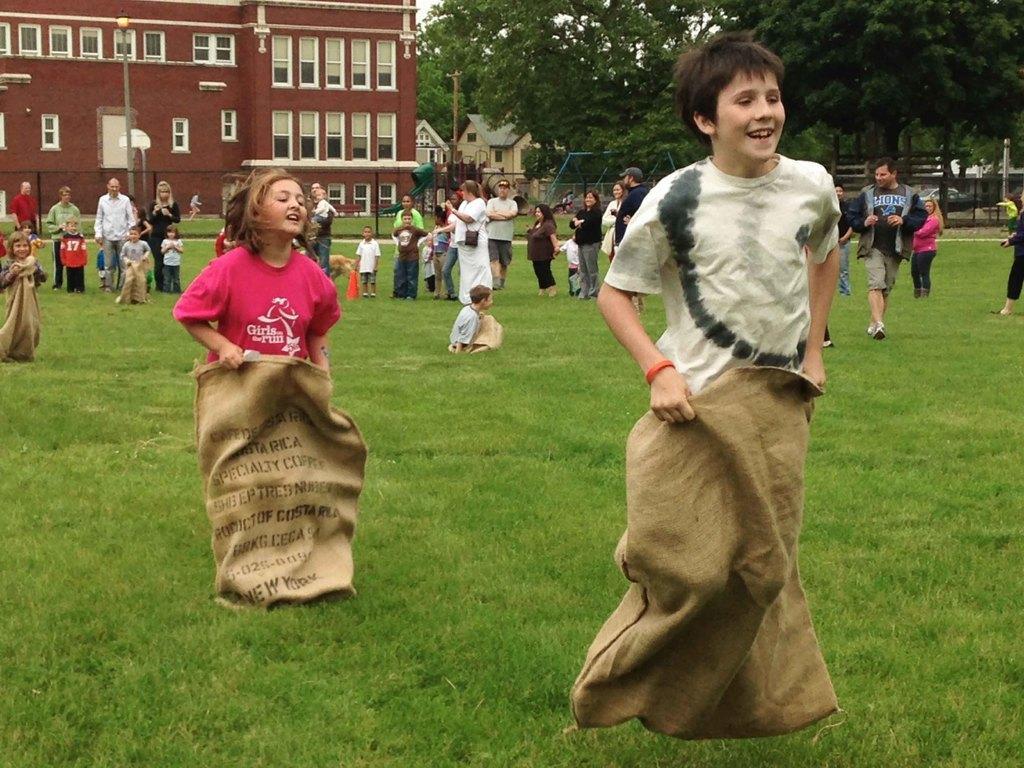Please provide a concise description of this image. Here in this picture we can see a group of children competing in a sack race on the ground, which is fully covered with grass and we can see they are smiling and behind them we can see other number of people standing and watching and we can also see a building with windows present and we can see lamp post present and we can see plants and trees present. 